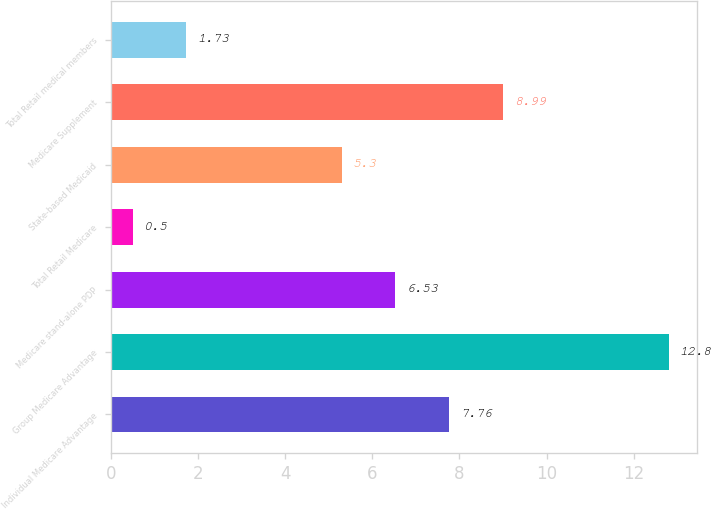Convert chart to OTSL. <chart><loc_0><loc_0><loc_500><loc_500><bar_chart><fcel>Individual Medicare Advantage<fcel>Group Medicare Advantage<fcel>Medicare stand-alone PDP<fcel>Total Retail Medicare<fcel>State-based Medicaid<fcel>Medicare Supplement<fcel>Total Retail medical members<nl><fcel>7.76<fcel>12.8<fcel>6.53<fcel>0.5<fcel>5.3<fcel>8.99<fcel>1.73<nl></chart> 